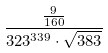<formula> <loc_0><loc_0><loc_500><loc_500>\frac { \frac { 9 } { 1 6 0 } } { 3 2 3 ^ { 3 3 9 } \cdot \sqrt { 3 8 3 } }</formula> 